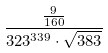<formula> <loc_0><loc_0><loc_500><loc_500>\frac { \frac { 9 } { 1 6 0 } } { 3 2 3 ^ { 3 3 9 } \cdot \sqrt { 3 8 3 } }</formula> 